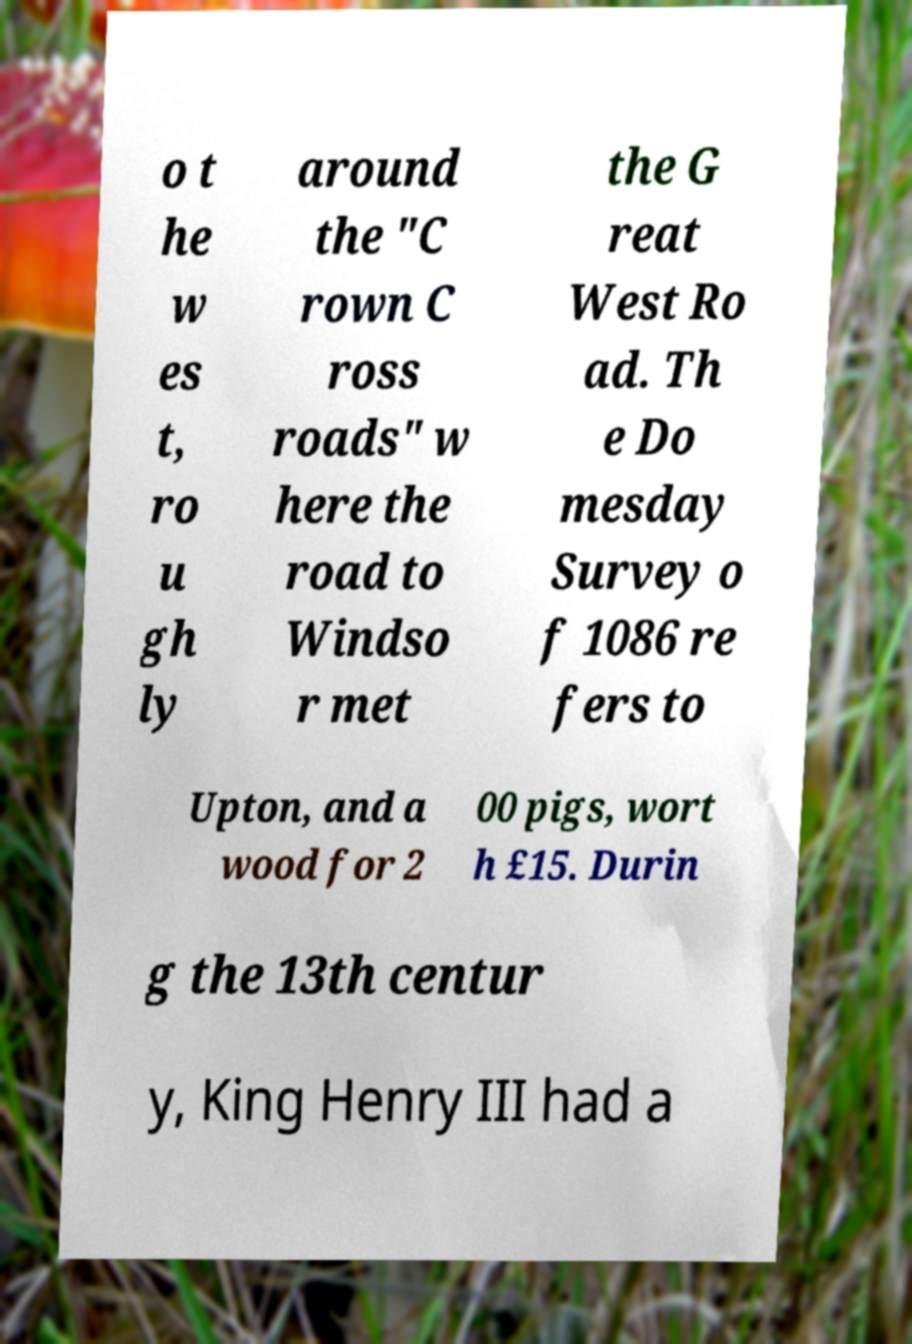I need the written content from this picture converted into text. Can you do that? o t he w es t, ro u gh ly around the "C rown C ross roads" w here the road to Windso r met the G reat West Ro ad. Th e Do mesday Survey o f 1086 re fers to Upton, and a wood for 2 00 pigs, wort h £15. Durin g the 13th centur y, King Henry III had a 